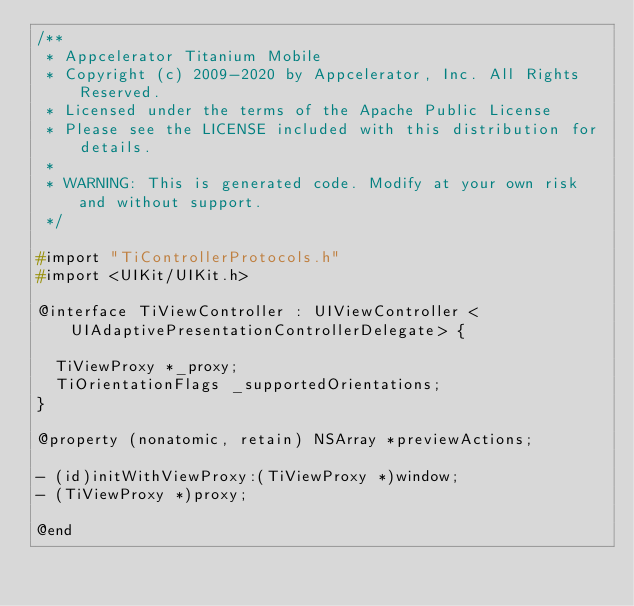<code> <loc_0><loc_0><loc_500><loc_500><_C_>/**
 * Appcelerator Titanium Mobile
 * Copyright (c) 2009-2020 by Appcelerator, Inc. All Rights Reserved.
 * Licensed under the terms of the Apache Public License
 * Please see the LICENSE included with this distribution for details.
 * 
 * WARNING: This is generated code. Modify at your own risk and without support.
 */

#import "TiControllerProtocols.h"
#import <UIKit/UIKit.h>

@interface TiViewController : UIViewController <UIAdaptivePresentationControllerDelegate> {

  TiViewProxy *_proxy;
  TiOrientationFlags _supportedOrientations;
}

@property (nonatomic, retain) NSArray *previewActions;

- (id)initWithViewProxy:(TiViewProxy *)window;
- (TiViewProxy *)proxy;

@end
</code> 